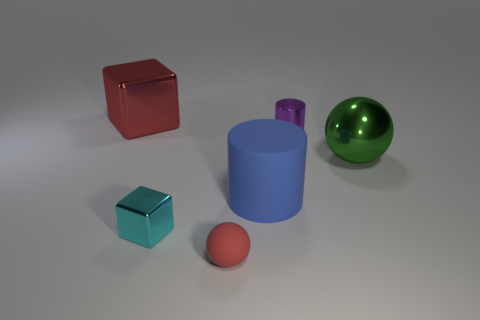Can you suggest a real-world scenario where these objects might be found together? Certainly! These objects might be found together as part of a color and material study in an artist's studio or a 3D modeling software's default scene used for render tests to evaluate lighting and texturing effects. 